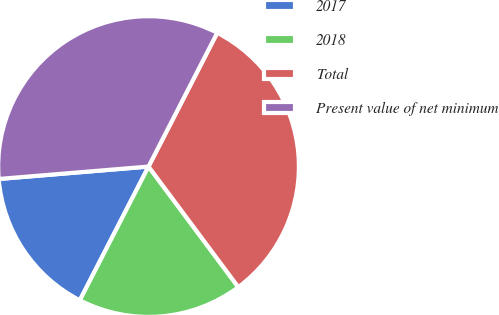Convert chart. <chart><loc_0><loc_0><loc_500><loc_500><pie_chart><fcel>2017<fcel>2018<fcel>Total<fcel>Present value of net minimum<nl><fcel>16.13%<fcel>17.74%<fcel>32.26%<fcel>33.87%<nl></chart> 